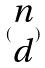Convert formula to latex. <formula><loc_0><loc_0><loc_500><loc_500>( \begin{matrix} n \\ d \end{matrix} )</formula> 